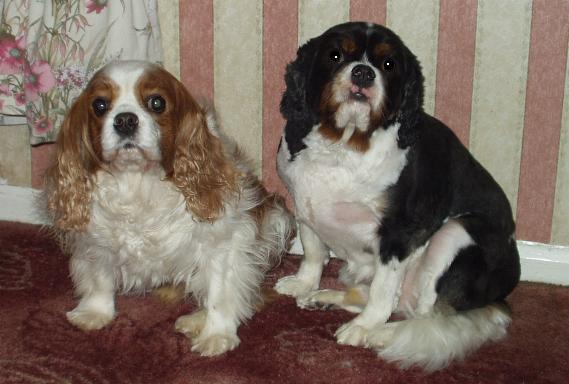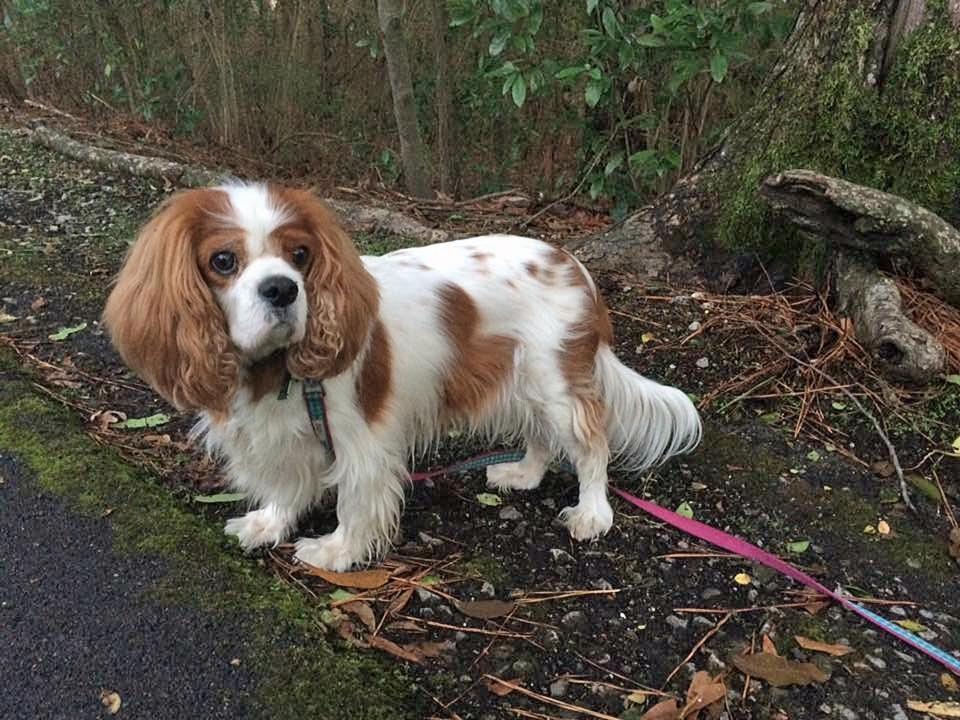The first image is the image on the left, the second image is the image on the right. Given the left and right images, does the statement "One image contains a brown-and-white spaniel next to a dog with darker markings, and the other image contains only one brown-and-white spaniel." hold true? Answer yes or no. Yes. The first image is the image on the left, the second image is the image on the right. Evaluate the accuracy of this statement regarding the images: "There are exactly two dogs in the left image.". Is it true? Answer yes or no. Yes. 